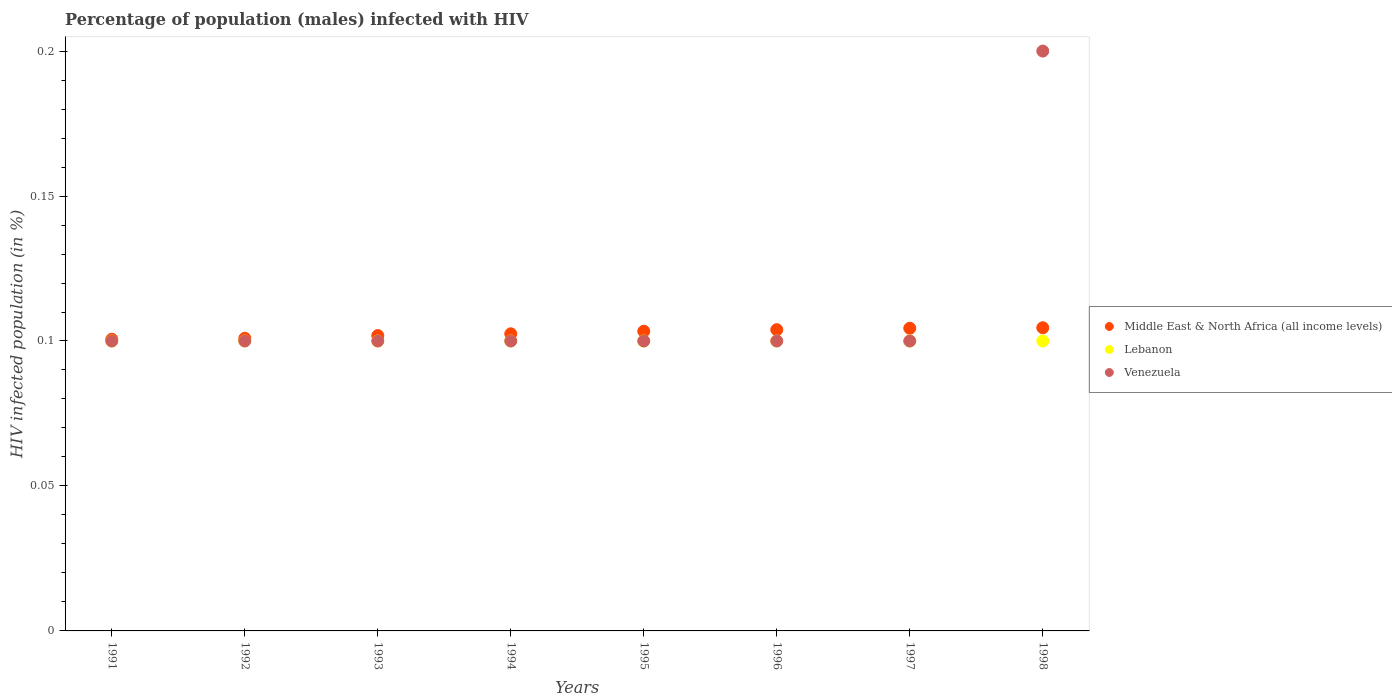How many different coloured dotlines are there?
Make the answer very short. 3. Is the number of dotlines equal to the number of legend labels?
Your answer should be very brief. Yes. Across all years, what is the maximum percentage of HIV infected male population in Venezuela?
Ensure brevity in your answer.  0.2. Across all years, what is the minimum percentage of HIV infected male population in Lebanon?
Your response must be concise. 0.1. In which year was the percentage of HIV infected male population in Lebanon maximum?
Your response must be concise. 1991. In which year was the percentage of HIV infected male population in Middle East & North Africa (all income levels) minimum?
Offer a terse response. 1991. What is the difference between the percentage of HIV infected male population in Venezuela in 1992 and that in 1998?
Your answer should be compact. -0.1. What is the difference between the percentage of HIV infected male population in Venezuela in 1992 and the percentage of HIV infected male population in Middle East & North Africa (all income levels) in 1996?
Provide a short and direct response. -0. What is the average percentage of HIV infected male population in Middle East & North Africa (all income levels) per year?
Offer a terse response. 0.1. What is the ratio of the percentage of HIV infected male population in Lebanon in 1996 to that in 1997?
Your response must be concise. 1. What is the difference between the highest and the lowest percentage of HIV infected male population in Venezuela?
Make the answer very short. 0.1. Is it the case that in every year, the sum of the percentage of HIV infected male population in Venezuela and percentage of HIV infected male population in Middle East & North Africa (all income levels)  is greater than the percentage of HIV infected male population in Lebanon?
Offer a very short reply. Yes. Does the percentage of HIV infected male population in Lebanon monotonically increase over the years?
Your answer should be compact. No. Is the percentage of HIV infected male population in Lebanon strictly less than the percentage of HIV infected male population in Venezuela over the years?
Offer a terse response. No. How many dotlines are there?
Give a very brief answer. 3. How many years are there in the graph?
Offer a terse response. 8. Does the graph contain any zero values?
Your answer should be very brief. No. Where does the legend appear in the graph?
Your response must be concise. Center right. How are the legend labels stacked?
Provide a succinct answer. Vertical. What is the title of the graph?
Keep it short and to the point. Percentage of population (males) infected with HIV. What is the label or title of the X-axis?
Keep it short and to the point. Years. What is the label or title of the Y-axis?
Ensure brevity in your answer.  HIV infected population (in %). What is the HIV infected population (in %) of Middle East & North Africa (all income levels) in 1991?
Provide a succinct answer. 0.1. What is the HIV infected population (in %) of Lebanon in 1991?
Provide a short and direct response. 0.1. What is the HIV infected population (in %) in Middle East & North Africa (all income levels) in 1992?
Make the answer very short. 0.1. What is the HIV infected population (in %) of Lebanon in 1992?
Keep it short and to the point. 0.1. What is the HIV infected population (in %) in Middle East & North Africa (all income levels) in 1993?
Ensure brevity in your answer.  0.1. What is the HIV infected population (in %) of Lebanon in 1993?
Give a very brief answer. 0.1. What is the HIV infected population (in %) of Venezuela in 1993?
Offer a terse response. 0.1. What is the HIV infected population (in %) of Middle East & North Africa (all income levels) in 1994?
Provide a succinct answer. 0.1. What is the HIV infected population (in %) of Venezuela in 1994?
Your answer should be compact. 0.1. What is the HIV infected population (in %) in Middle East & North Africa (all income levels) in 1995?
Give a very brief answer. 0.1. What is the HIV infected population (in %) of Middle East & North Africa (all income levels) in 1996?
Keep it short and to the point. 0.1. What is the HIV infected population (in %) of Middle East & North Africa (all income levels) in 1997?
Provide a succinct answer. 0.1. What is the HIV infected population (in %) in Venezuela in 1997?
Offer a terse response. 0.1. What is the HIV infected population (in %) of Middle East & North Africa (all income levels) in 1998?
Your response must be concise. 0.1. What is the HIV infected population (in %) in Lebanon in 1998?
Make the answer very short. 0.1. Across all years, what is the maximum HIV infected population (in %) of Middle East & North Africa (all income levels)?
Offer a terse response. 0.1. Across all years, what is the maximum HIV infected population (in %) in Venezuela?
Provide a succinct answer. 0.2. Across all years, what is the minimum HIV infected population (in %) of Middle East & North Africa (all income levels)?
Make the answer very short. 0.1. What is the total HIV infected population (in %) in Middle East & North Africa (all income levels) in the graph?
Your answer should be compact. 0.82. What is the total HIV infected population (in %) in Venezuela in the graph?
Offer a terse response. 0.9. What is the difference between the HIV infected population (in %) in Middle East & North Africa (all income levels) in 1991 and that in 1992?
Give a very brief answer. -0. What is the difference between the HIV infected population (in %) of Venezuela in 1991 and that in 1992?
Your response must be concise. 0. What is the difference between the HIV infected population (in %) of Middle East & North Africa (all income levels) in 1991 and that in 1993?
Your response must be concise. -0. What is the difference between the HIV infected population (in %) in Lebanon in 1991 and that in 1993?
Your response must be concise. 0. What is the difference between the HIV infected population (in %) of Middle East & North Africa (all income levels) in 1991 and that in 1994?
Offer a terse response. -0. What is the difference between the HIV infected population (in %) of Venezuela in 1991 and that in 1994?
Keep it short and to the point. 0. What is the difference between the HIV infected population (in %) in Middle East & North Africa (all income levels) in 1991 and that in 1995?
Your answer should be very brief. -0. What is the difference between the HIV infected population (in %) in Lebanon in 1991 and that in 1995?
Your answer should be compact. 0. What is the difference between the HIV infected population (in %) in Middle East & North Africa (all income levels) in 1991 and that in 1996?
Keep it short and to the point. -0. What is the difference between the HIV infected population (in %) in Lebanon in 1991 and that in 1996?
Provide a succinct answer. 0. What is the difference between the HIV infected population (in %) in Venezuela in 1991 and that in 1996?
Your answer should be very brief. 0. What is the difference between the HIV infected population (in %) of Middle East & North Africa (all income levels) in 1991 and that in 1997?
Offer a terse response. -0. What is the difference between the HIV infected population (in %) in Venezuela in 1991 and that in 1997?
Ensure brevity in your answer.  0. What is the difference between the HIV infected population (in %) in Middle East & North Africa (all income levels) in 1991 and that in 1998?
Make the answer very short. -0. What is the difference between the HIV infected population (in %) in Middle East & North Africa (all income levels) in 1992 and that in 1993?
Give a very brief answer. -0. What is the difference between the HIV infected population (in %) of Middle East & North Africa (all income levels) in 1992 and that in 1994?
Give a very brief answer. -0. What is the difference between the HIV infected population (in %) in Middle East & North Africa (all income levels) in 1992 and that in 1995?
Offer a terse response. -0. What is the difference between the HIV infected population (in %) in Venezuela in 1992 and that in 1995?
Provide a short and direct response. 0. What is the difference between the HIV infected population (in %) of Middle East & North Africa (all income levels) in 1992 and that in 1996?
Offer a terse response. -0. What is the difference between the HIV infected population (in %) in Lebanon in 1992 and that in 1996?
Your answer should be compact. 0. What is the difference between the HIV infected population (in %) in Middle East & North Africa (all income levels) in 1992 and that in 1997?
Provide a succinct answer. -0. What is the difference between the HIV infected population (in %) in Lebanon in 1992 and that in 1997?
Make the answer very short. 0. What is the difference between the HIV infected population (in %) in Middle East & North Africa (all income levels) in 1992 and that in 1998?
Provide a succinct answer. -0. What is the difference between the HIV infected population (in %) in Venezuela in 1992 and that in 1998?
Offer a very short reply. -0.1. What is the difference between the HIV infected population (in %) of Middle East & North Africa (all income levels) in 1993 and that in 1994?
Keep it short and to the point. -0. What is the difference between the HIV infected population (in %) in Lebanon in 1993 and that in 1994?
Give a very brief answer. 0. What is the difference between the HIV infected population (in %) in Middle East & North Africa (all income levels) in 1993 and that in 1995?
Give a very brief answer. -0. What is the difference between the HIV infected population (in %) in Lebanon in 1993 and that in 1995?
Provide a succinct answer. 0. What is the difference between the HIV infected population (in %) in Venezuela in 1993 and that in 1995?
Provide a succinct answer. 0. What is the difference between the HIV infected population (in %) in Middle East & North Africa (all income levels) in 1993 and that in 1996?
Your answer should be compact. -0. What is the difference between the HIV infected population (in %) of Lebanon in 1993 and that in 1996?
Provide a succinct answer. 0. What is the difference between the HIV infected population (in %) in Venezuela in 1993 and that in 1996?
Keep it short and to the point. 0. What is the difference between the HIV infected population (in %) of Middle East & North Africa (all income levels) in 1993 and that in 1997?
Provide a short and direct response. -0. What is the difference between the HIV infected population (in %) in Lebanon in 1993 and that in 1997?
Offer a very short reply. 0. What is the difference between the HIV infected population (in %) in Venezuela in 1993 and that in 1997?
Make the answer very short. 0. What is the difference between the HIV infected population (in %) in Middle East & North Africa (all income levels) in 1993 and that in 1998?
Give a very brief answer. -0. What is the difference between the HIV infected population (in %) of Lebanon in 1993 and that in 1998?
Make the answer very short. 0. What is the difference between the HIV infected population (in %) of Middle East & North Africa (all income levels) in 1994 and that in 1995?
Provide a short and direct response. -0. What is the difference between the HIV infected population (in %) of Middle East & North Africa (all income levels) in 1994 and that in 1996?
Make the answer very short. -0. What is the difference between the HIV infected population (in %) in Venezuela in 1994 and that in 1996?
Provide a succinct answer. 0. What is the difference between the HIV infected population (in %) of Middle East & North Africa (all income levels) in 1994 and that in 1997?
Your answer should be very brief. -0. What is the difference between the HIV infected population (in %) in Lebanon in 1994 and that in 1997?
Offer a very short reply. 0. What is the difference between the HIV infected population (in %) of Middle East & North Africa (all income levels) in 1994 and that in 1998?
Make the answer very short. -0. What is the difference between the HIV infected population (in %) in Lebanon in 1994 and that in 1998?
Offer a very short reply. 0. What is the difference between the HIV infected population (in %) in Middle East & North Africa (all income levels) in 1995 and that in 1996?
Your answer should be compact. -0. What is the difference between the HIV infected population (in %) of Lebanon in 1995 and that in 1996?
Keep it short and to the point. 0. What is the difference between the HIV infected population (in %) in Venezuela in 1995 and that in 1996?
Provide a succinct answer. 0. What is the difference between the HIV infected population (in %) in Middle East & North Africa (all income levels) in 1995 and that in 1997?
Your answer should be compact. -0. What is the difference between the HIV infected population (in %) in Venezuela in 1995 and that in 1997?
Ensure brevity in your answer.  0. What is the difference between the HIV infected population (in %) of Middle East & North Africa (all income levels) in 1995 and that in 1998?
Provide a short and direct response. -0. What is the difference between the HIV infected population (in %) of Lebanon in 1995 and that in 1998?
Ensure brevity in your answer.  0. What is the difference between the HIV infected population (in %) of Venezuela in 1995 and that in 1998?
Keep it short and to the point. -0.1. What is the difference between the HIV infected population (in %) of Middle East & North Africa (all income levels) in 1996 and that in 1997?
Give a very brief answer. -0. What is the difference between the HIV infected population (in %) of Lebanon in 1996 and that in 1997?
Your response must be concise. 0. What is the difference between the HIV infected population (in %) in Venezuela in 1996 and that in 1997?
Provide a succinct answer. 0. What is the difference between the HIV infected population (in %) in Middle East & North Africa (all income levels) in 1996 and that in 1998?
Make the answer very short. -0. What is the difference between the HIV infected population (in %) in Lebanon in 1996 and that in 1998?
Give a very brief answer. 0. What is the difference between the HIV infected population (in %) of Venezuela in 1996 and that in 1998?
Offer a terse response. -0.1. What is the difference between the HIV infected population (in %) of Middle East & North Africa (all income levels) in 1997 and that in 1998?
Keep it short and to the point. -0. What is the difference between the HIV infected population (in %) of Lebanon in 1997 and that in 1998?
Make the answer very short. 0. What is the difference between the HIV infected population (in %) in Middle East & North Africa (all income levels) in 1991 and the HIV infected population (in %) in Lebanon in 1992?
Provide a succinct answer. 0. What is the difference between the HIV infected population (in %) in Middle East & North Africa (all income levels) in 1991 and the HIV infected population (in %) in Venezuela in 1992?
Give a very brief answer. 0. What is the difference between the HIV infected population (in %) in Middle East & North Africa (all income levels) in 1991 and the HIV infected population (in %) in Lebanon in 1993?
Ensure brevity in your answer.  0. What is the difference between the HIV infected population (in %) of Middle East & North Africa (all income levels) in 1991 and the HIV infected population (in %) of Venezuela in 1993?
Ensure brevity in your answer.  0. What is the difference between the HIV infected population (in %) in Middle East & North Africa (all income levels) in 1991 and the HIV infected population (in %) in Lebanon in 1994?
Make the answer very short. 0. What is the difference between the HIV infected population (in %) in Middle East & North Africa (all income levels) in 1991 and the HIV infected population (in %) in Venezuela in 1994?
Provide a short and direct response. 0. What is the difference between the HIV infected population (in %) of Middle East & North Africa (all income levels) in 1991 and the HIV infected population (in %) of Lebanon in 1995?
Ensure brevity in your answer.  0. What is the difference between the HIV infected population (in %) of Middle East & North Africa (all income levels) in 1991 and the HIV infected population (in %) of Venezuela in 1995?
Offer a terse response. 0. What is the difference between the HIV infected population (in %) in Middle East & North Africa (all income levels) in 1991 and the HIV infected population (in %) in Lebanon in 1996?
Provide a short and direct response. 0. What is the difference between the HIV infected population (in %) of Middle East & North Africa (all income levels) in 1991 and the HIV infected population (in %) of Venezuela in 1996?
Make the answer very short. 0. What is the difference between the HIV infected population (in %) of Lebanon in 1991 and the HIV infected population (in %) of Venezuela in 1996?
Ensure brevity in your answer.  0. What is the difference between the HIV infected population (in %) in Middle East & North Africa (all income levels) in 1991 and the HIV infected population (in %) in Lebanon in 1997?
Provide a succinct answer. 0. What is the difference between the HIV infected population (in %) in Middle East & North Africa (all income levels) in 1991 and the HIV infected population (in %) in Venezuela in 1997?
Your response must be concise. 0. What is the difference between the HIV infected population (in %) of Middle East & North Africa (all income levels) in 1991 and the HIV infected population (in %) of Lebanon in 1998?
Give a very brief answer. 0. What is the difference between the HIV infected population (in %) in Middle East & North Africa (all income levels) in 1991 and the HIV infected population (in %) in Venezuela in 1998?
Ensure brevity in your answer.  -0.1. What is the difference between the HIV infected population (in %) of Lebanon in 1991 and the HIV infected population (in %) of Venezuela in 1998?
Your answer should be very brief. -0.1. What is the difference between the HIV infected population (in %) in Middle East & North Africa (all income levels) in 1992 and the HIV infected population (in %) in Lebanon in 1993?
Your answer should be compact. 0. What is the difference between the HIV infected population (in %) in Middle East & North Africa (all income levels) in 1992 and the HIV infected population (in %) in Venezuela in 1993?
Give a very brief answer. 0. What is the difference between the HIV infected population (in %) in Middle East & North Africa (all income levels) in 1992 and the HIV infected population (in %) in Lebanon in 1994?
Give a very brief answer. 0. What is the difference between the HIV infected population (in %) in Middle East & North Africa (all income levels) in 1992 and the HIV infected population (in %) in Venezuela in 1994?
Provide a succinct answer. 0. What is the difference between the HIV infected population (in %) of Middle East & North Africa (all income levels) in 1992 and the HIV infected population (in %) of Lebanon in 1995?
Give a very brief answer. 0. What is the difference between the HIV infected population (in %) in Middle East & North Africa (all income levels) in 1992 and the HIV infected population (in %) in Venezuela in 1995?
Offer a very short reply. 0. What is the difference between the HIV infected population (in %) in Middle East & North Africa (all income levels) in 1992 and the HIV infected population (in %) in Lebanon in 1996?
Your response must be concise. 0. What is the difference between the HIV infected population (in %) of Middle East & North Africa (all income levels) in 1992 and the HIV infected population (in %) of Venezuela in 1996?
Offer a very short reply. 0. What is the difference between the HIV infected population (in %) in Middle East & North Africa (all income levels) in 1992 and the HIV infected population (in %) in Lebanon in 1997?
Your response must be concise. 0. What is the difference between the HIV infected population (in %) in Middle East & North Africa (all income levels) in 1992 and the HIV infected population (in %) in Venezuela in 1997?
Make the answer very short. 0. What is the difference between the HIV infected population (in %) in Middle East & North Africa (all income levels) in 1992 and the HIV infected population (in %) in Lebanon in 1998?
Ensure brevity in your answer.  0. What is the difference between the HIV infected population (in %) of Middle East & North Africa (all income levels) in 1992 and the HIV infected population (in %) of Venezuela in 1998?
Make the answer very short. -0.1. What is the difference between the HIV infected population (in %) of Middle East & North Africa (all income levels) in 1993 and the HIV infected population (in %) of Lebanon in 1994?
Offer a terse response. 0. What is the difference between the HIV infected population (in %) of Middle East & North Africa (all income levels) in 1993 and the HIV infected population (in %) of Venezuela in 1994?
Your answer should be compact. 0. What is the difference between the HIV infected population (in %) in Middle East & North Africa (all income levels) in 1993 and the HIV infected population (in %) in Lebanon in 1995?
Provide a short and direct response. 0. What is the difference between the HIV infected population (in %) in Middle East & North Africa (all income levels) in 1993 and the HIV infected population (in %) in Venezuela in 1995?
Ensure brevity in your answer.  0. What is the difference between the HIV infected population (in %) in Lebanon in 1993 and the HIV infected population (in %) in Venezuela in 1995?
Offer a very short reply. 0. What is the difference between the HIV infected population (in %) of Middle East & North Africa (all income levels) in 1993 and the HIV infected population (in %) of Lebanon in 1996?
Ensure brevity in your answer.  0. What is the difference between the HIV infected population (in %) of Middle East & North Africa (all income levels) in 1993 and the HIV infected population (in %) of Venezuela in 1996?
Your answer should be very brief. 0. What is the difference between the HIV infected population (in %) of Lebanon in 1993 and the HIV infected population (in %) of Venezuela in 1996?
Your response must be concise. 0. What is the difference between the HIV infected population (in %) of Middle East & North Africa (all income levels) in 1993 and the HIV infected population (in %) of Lebanon in 1997?
Provide a short and direct response. 0. What is the difference between the HIV infected population (in %) of Middle East & North Africa (all income levels) in 1993 and the HIV infected population (in %) of Venezuela in 1997?
Make the answer very short. 0. What is the difference between the HIV infected population (in %) of Lebanon in 1993 and the HIV infected population (in %) of Venezuela in 1997?
Make the answer very short. 0. What is the difference between the HIV infected population (in %) in Middle East & North Africa (all income levels) in 1993 and the HIV infected population (in %) in Lebanon in 1998?
Your answer should be very brief. 0. What is the difference between the HIV infected population (in %) in Middle East & North Africa (all income levels) in 1993 and the HIV infected population (in %) in Venezuela in 1998?
Make the answer very short. -0.1. What is the difference between the HIV infected population (in %) of Middle East & North Africa (all income levels) in 1994 and the HIV infected population (in %) of Lebanon in 1995?
Offer a terse response. 0. What is the difference between the HIV infected population (in %) of Middle East & North Africa (all income levels) in 1994 and the HIV infected population (in %) of Venezuela in 1995?
Your answer should be very brief. 0. What is the difference between the HIV infected population (in %) of Middle East & North Africa (all income levels) in 1994 and the HIV infected population (in %) of Lebanon in 1996?
Your answer should be very brief. 0. What is the difference between the HIV infected population (in %) of Middle East & North Africa (all income levels) in 1994 and the HIV infected population (in %) of Venezuela in 1996?
Give a very brief answer. 0. What is the difference between the HIV infected population (in %) of Lebanon in 1994 and the HIV infected population (in %) of Venezuela in 1996?
Make the answer very short. 0. What is the difference between the HIV infected population (in %) of Middle East & North Africa (all income levels) in 1994 and the HIV infected population (in %) of Lebanon in 1997?
Provide a short and direct response. 0. What is the difference between the HIV infected population (in %) in Middle East & North Africa (all income levels) in 1994 and the HIV infected population (in %) in Venezuela in 1997?
Offer a very short reply. 0. What is the difference between the HIV infected population (in %) in Lebanon in 1994 and the HIV infected population (in %) in Venezuela in 1997?
Your answer should be very brief. 0. What is the difference between the HIV infected population (in %) of Middle East & North Africa (all income levels) in 1994 and the HIV infected population (in %) of Lebanon in 1998?
Give a very brief answer. 0. What is the difference between the HIV infected population (in %) of Middle East & North Africa (all income levels) in 1994 and the HIV infected population (in %) of Venezuela in 1998?
Offer a terse response. -0.1. What is the difference between the HIV infected population (in %) of Lebanon in 1994 and the HIV infected population (in %) of Venezuela in 1998?
Offer a very short reply. -0.1. What is the difference between the HIV infected population (in %) of Middle East & North Africa (all income levels) in 1995 and the HIV infected population (in %) of Lebanon in 1996?
Offer a terse response. 0. What is the difference between the HIV infected population (in %) in Middle East & North Africa (all income levels) in 1995 and the HIV infected population (in %) in Venezuela in 1996?
Give a very brief answer. 0. What is the difference between the HIV infected population (in %) of Middle East & North Africa (all income levels) in 1995 and the HIV infected population (in %) of Lebanon in 1997?
Offer a terse response. 0. What is the difference between the HIV infected population (in %) in Middle East & North Africa (all income levels) in 1995 and the HIV infected population (in %) in Venezuela in 1997?
Offer a very short reply. 0. What is the difference between the HIV infected population (in %) of Middle East & North Africa (all income levels) in 1995 and the HIV infected population (in %) of Lebanon in 1998?
Offer a very short reply. 0. What is the difference between the HIV infected population (in %) in Middle East & North Africa (all income levels) in 1995 and the HIV infected population (in %) in Venezuela in 1998?
Your answer should be compact. -0.1. What is the difference between the HIV infected population (in %) of Lebanon in 1995 and the HIV infected population (in %) of Venezuela in 1998?
Make the answer very short. -0.1. What is the difference between the HIV infected population (in %) of Middle East & North Africa (all income levels) in 1996 and the HIV infected population (in %) of Lebanon in 1997?
Ensure brevity in your answer.  0. What is the difference between the HIV infected population (in %) in Middle East & North Africa (all income levels) in 1996 and the HIV infected population (in %) in Venezuela in 1997?
Provide a succinct answer. 0. What is the difference between the HIV infected population (in %) in Middle East & North Africa (all income levels) in 1996 and the HIV infected population (in %) in Lebanon in 1998?
Make the answer very short. 0. What is the difference between the HIV infected population (in %) of Middle East & North Africa (all income levels) in 1996 and the HIV infected population (in %) of Venezuela in 1998?
Make the answer very short. -0.1. What is the difference between the HIV infected population (in %) in Lebanon in 1996 and the HIV infected population (in %) in Venezuela in 1998?
Make the answer very short. -0.1. What is the difference between the HIV infected population (in %) in Middle East & North Africa (all income levels) in 1997 and the HIV infected population (in %) in Lebanon in 1998?
Make the answer very short. 0. What is the difference between the HIV infected population (in %) of Middle East & North Africa (all income levels) in 1997 and the HIV infected population (in %) of Venezuela in 1998?
Offer a terse response. -0.1. What is the average HIV infected population (in %) in Middle East & North Africa (all income levels) per year?
Your answer should be very brief. 0.1. What is the average HIV infected population (in %) of Venezuela per year?
Offer a terse response. 0.11. In the year 1991, what is the difference between the HIV infected population (in %) in Middle East & North Africa (all income levels) and HIV infected population (in %) in Lebanon?
Keep it short and to the point. 0. In the year 1991, what is the difference between the HIV infected population (in %) of Middle East & North Africa (all income levels) and HIV infected population (in %) of Venezuela?
Make the answer very short. 0. In the year 1992, what is the difference between the HIV infected population (in %) of Middle East & North Africa (all income levels) and HIV infected population (in %) of Lebanon?
Ensure brevity in your answer.  0. In the year 1992, what is the difference between the HIV infected population (in %) of Middle East & North Africa (all income levels) and HIV infected population (in %) of Venezuela?
Provide a short and direct response. 0. In the year 1992, what is the difference between the HIV infected population (in %) in Lebanon and HIV infected population (in %) in Venezuela?
Offer a terse response. 0. In the year 1993, what is the difference between the HIV infected population (in %) in Middle East & North Africa (all income levels) and HIV infected population (in %) in Lebanon?
Give a very brief answer. 0. In the year 1993, what is the difference between the HIV infected population (in %) in Middle East & North Africa (all income levels) and HIV infected population (in %) in Venezuela?
Your answer should be very brief. 0. In the year 1994, what is the difference between the HIV infected population (in %) of Middle East & North Africa (all income levels) and HIV infected population (in %) of Lebanon?
Give a very brief answer. 0. In the year 1994, what is the difference between the HIV infected population (in %) of Middle East & North Africa (all income levels) and HIV infected population (in %) of Venezuela?
Offer a very short reply. 0. In the year 1994, what is the difference between the HIV infected population (in %) in Lebanon and HIV infected population (in %) in Venezuela?
Keep it short and to the point. 0. In the year 1995, what is the difference between the HIV infected population (in %) of Middle East & North Africa (all income levels) and HIV infected population (in %) of Lebanon?
Keep it short and to the point. 0. In the year 1995, what is the difference between the HIV infected population (in %) in Middle East & North Africa (all income levels) and HIV infected population (in %) in Venezuela?
Your response must be concise. 0. In the year 1995, what is the difference between the HIV infected population (in %) in Lebanon and HIV infected population (in %) in Venezuela?
Offer a terse response. 0. In the year 1996, what is the difference between the HIV infected population (in %) of Middle East & North Africa (all income levels) and HIV infected population (in %) of Lebanon?
Provide a short and direct response. 0. In the year 1996, what is the difference between the HIV infected population (in %) of Middle East & North Africa (all income levels) and HIV infected population (in %) of Venezuela?
Provide a succinct answer. 0. In the year 1996, what is the difference between the HIV infected population (in %) in Lebanon and HIV infected population (in %) in Venezuela?
Your answer should be very brief. 0. In the year 1997, what is the difference between the HIV infected population (in %) of Middle East & North Africa (all income levels) and HIV infected population (in %) of Lebanon?
Make the answer very short. 0. In the year 1997, what is the difference between the HIV infected population (in %) in Middle East & North Africa (all income levels) and HIV infected population (in %) in Venezuela?
Your answer should be very brief. 0. In the year 1997, what is the difference between the HIV infected population (in %) of Lebanon and HIV infected population (in %) of Venezuela?
Your answer should be very brief. 0. In the year 1998, what is the difference between the HIV infected population (in %) in Middle East & North Africa (all income levels) and HIV infected population (in %) in Lebanon?
Give a very brief answer. 0. In the year 1998, what is the difference between the HIV infected population (in %) of Middle East & North Africa (all income levels) and HIV infected population (in %) of Venezuela?
Offer a terse response. -0.1. In the year 1998, what is the difference between the HIV infected population (in %) in Lebanon and HIV infected population (in %) in Venezuela?
Give a very brief answer. -0.1. What is the ratio of the HIV infected population (in %) in Lebanon in 1991 to that in 1992?
Your answer should be compact. 1. What is the ratio of the HIV infected population (in %) of Lebanon in 1991 to that in 1993?
Provide a succinct answer. 1. What is the ratio of the HIV infected population (in %) of Venezuela in 1991 to that in 1993?
Your answer should be very brief. 1. What is the ratio of the HIV infected population (in %) in Middle East & North Africa (all income levels) in 1991 to that in 1994?
Offer a very short reply. 0.98. What is the ratio of the HIV infected population (in %) in Lebanon in 1991 to that in 1994?
Provide a short and direct response. 1. What is the ratio of the HIV infected population (in %) in Middle East & North Africa (all income levels) in 1991 to that in 1995?
Ensure brevity in your answer.  0.97. What is the ratio of the HIV infected population (in %) of Lebanon in 1991 to that in 1995?
Ensure brevity in your answer.  1. What is the ratio of the HIV infected population (in %) in Venezuela in 1991 to that in 1995?
Make the answer very short. 1. What is the ratio of the HIV infected population (in %) in Middle East & North Africa (all income levels) in 1991 to that in 1996?
Your answer should be very brief. 0.97. What is the ratio of the HIV infected population (in %) of Venezuela in 1991 to that in 1996?
Ensure brevity in your answer.  1. What is the ratio of the HIV infected population (in %) in Middle East & North Africa (all income levels) in 1991 to that in 1997?
Ensure brevity in your answer.  0.96. What is the ratio of the HIV infected population (in %) in Lebanon in 1991 to that in 1997?
Your response must be concise. 1. What is the ratio of the HIV infected population (in %) of Middle East & North Africa (all income levels) in 1991 to that in 1998?
Provide a short and direct response. 0.96. What is the ratio of the HIV infected population (in %) of Venezuela in 1991 to that in 1998?
Your answer should be compact. 0.5. What is the ratio of the HIV infected population (in %) of Lebanon in 1992 to that in 1993?
Your response must be concise. 1. What is the ratio of the HIV infected population (in %) in Middle East & North Africa (all income levels) in 1992 to that in 1994?
Make the answer very short. 0.98. What is the ratio of the HIV infected population (in %) of Lebanon in 1992 to that in 1994?
Your answer should be very brief. 1. What is the ratio of the HIV infected population (in %) of Venezuela in 1992 to that in 1994?
Your response must be concise. 1. What is the ratio of the HIV infected population (in %) of Middle East & North Africa (all income levels) in 1992 to that in 1995?
Keep it short and to the point. 0.98. What is the ratio of the HIV infected population (in %) of Lebanon in 1992 to that in 1995?
Give a very brief answer. 1. What is the ratio of the HIV infected population (in %) of Venezuela in 1992 to that in 1995?
Offer a very short reply. 1. What is the ratio of the HIV infected population (in %) of Middle East & North Africa (all income levels) in 1992 to that in 1996?
Your response must be concise. 0.97. What is the ratio of the HIV infected population (in %) of Lebanon in 1992 to that in 1996?
Provide a succinct answer. 1. What is the ratio of the HIV infected population (in %) in Middle East & North Africa (all income levels) in 1992 to that in 1997?
Your response must be concise. 0.97. What is the ratio of the HIV infected population (in %) in Lebanon in 1992 to that in 1997?
Your response must be concise. 1. What is the ratio of the HIV infected population (in %) in Middle East & North Africa (all income levels) in 1992 to that in 1998?
Offer a very short reply. 0.97. What is the ratio of the HIV infected population (in %) in Middle East & North Africa (all income levels) in 1993 to that in 1994?
Offer a very short reply. 0.99. What is the ratio of the HIV infected population (in %) in Middle East & North Africa (all income levels) in 1993 to that in 1995?
Offer a terse response. 0.99. What is the ratio of the HIV infected population (in %) of Lebanon in 1993 to that in 1995?
Keep it short and to the point. 1. What is the ratio of the HIV infected population (in %) in Middle East & North Africa (all income levels) in 1993 to that in 1996?
Keep it short and to the point. 0.98. What is the ratio of the HIV infected population (in %) of Middle East & North Africa (all income levels) in 1993 to that in 1997?
Provide a short and direct response. 0.98. What is the ratio of the HIV infected population (in %) of Middle East & North Africa (all income levels) in 1993 to that in 1998?
Keep it short and to the point. 0.97. What is the ratio of the HIV infected population (in %) of Middle East & North Africa (all income levels) in 1994 to that in 1995?
Offer a very short reply. 0.99. What is the ratio of the HIV infected population (in %) in Lebanon in 1994 to that in 1995?
Provide a short and direct response. 1. What is the ratio of the HIV infected population (in %) in Venezuela in 1994 to that in 1995?
Provide a succinct answer. 1. What is the ratio of the HIV infected population (in %) of Middle East & North Africa (all income levels) in 1994 to that in 1996?
Offer a terse response. 0.99. What is the ratio of the HIV infected population (in %) of Lebanon in 1994 to that in 1996?
Your response must be concise. 1. What is the ratio of the HIV infected population (in %) of Venezuela in 1994 to that in 1996?
Offer a terse response. 1. What is the ratio of the HIV infected population (in %) in Middle East & North Africa (all income levels) in 1994 to that in 1997?
Make the answer very short. 0.98. What is the ratio of the HIV infected population (in %) of Lebanon in 1994 to that in 1997?
Your response must be concise. 1. What is the ratio of the HIV infected population (in %) of Venezuela in 1994 to that in 1997?
Offer a very short reply. 1. What is the ratio of the HIV infected population (in %) of Middle East & North Africa (all income levels) in 1994 to that in 1998?
Offer a terse response. 0.98. What is the ratio of the HIV infected population (in %) in Lebanon in 1994 to that in 1998?
Ensure brevity in your answer.  1. What is the ratio of the HIV infected population (in %) of Middle East & North Africa (all income levels) in 1995 to that in 1996?
Make the answer very short. 0.99. What is the ratio of the HIV infected population (in %) of Middle East & North Africa (all income levels) in 1995 to that in 1997?
Your response must be concise. 0.99. What is the ratio of the HIV infected population (in %) in Lebanon in 1995 to that in 1997?
Offer a terse response. 1. What is the ratio of the HIV infected population (in %) of Middle East & North Africa (all income levels) in 1995 to that in 1998?
Offer a terse response. 0.99. What is the ratio of the HIV infected population (in %) of Lebanon in 1996 to that in 1998?
Keep it short and to the point. 1. What is the ratio of the HIV infected population (in %) in Venezuela in 1996 to that in 1998?
Give a very brief answer. 0.5. What is the ratio of the HIV infected population (in %) in Middle East & North Africa (all income levels) in 1997 to that in 1998?
Provide a succinct answer. 1. What is the difference between the highest and the second highest HIV infected population (in %) in Lebanon?
Give a very brief answer. 0. What is the difference between the highest and the lowest HIV infected population (in %) of Middle East & North Africa (all income levels)?
Provide a succinct answer. 0. 